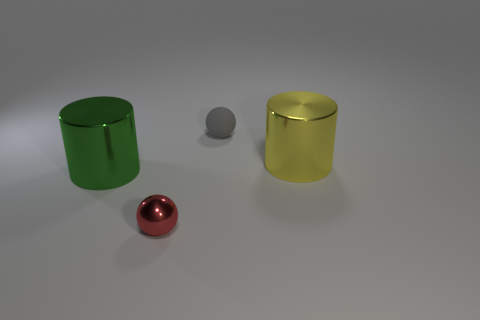There is another object that is the same shape as the small metallic thing; what is it made of?
Ensure brevity in your answer.  Rubber. Is there anything else that has the same material as the small gray object?
Offer a very short reply. No. What number of cylinders are either large shiny objects or yellow things?
Provide a short and direct response. 2. Is the size of the metal thing that is on the left side of the red metal sphere the same as the sphere that is in front of the tiny gray matte ball?
Provide a short and direct response. No. What material is the large object in front of the big metal cylinder right of the tiny matte thing?
Ensure brevity in your answer.  Metal. Is the number of big metallic cylinders that are in front of the large yellow object less than the number of green metal cylinders?
Your answer should be very brief. No. What is the shape of the large thing that is made of the same material as the big green cylinder?
Offer a very short reply. Cylinder. How many other things are the same shape as the tiny rubber thing?
Give a very brief answer. 1. How many brown things are shiny balls or tiny rubber objects?
Provide a short and direct response. 0. Is the shape of the tiny shiny object the same as the yellow thing?
Give a very brief answer. No. 